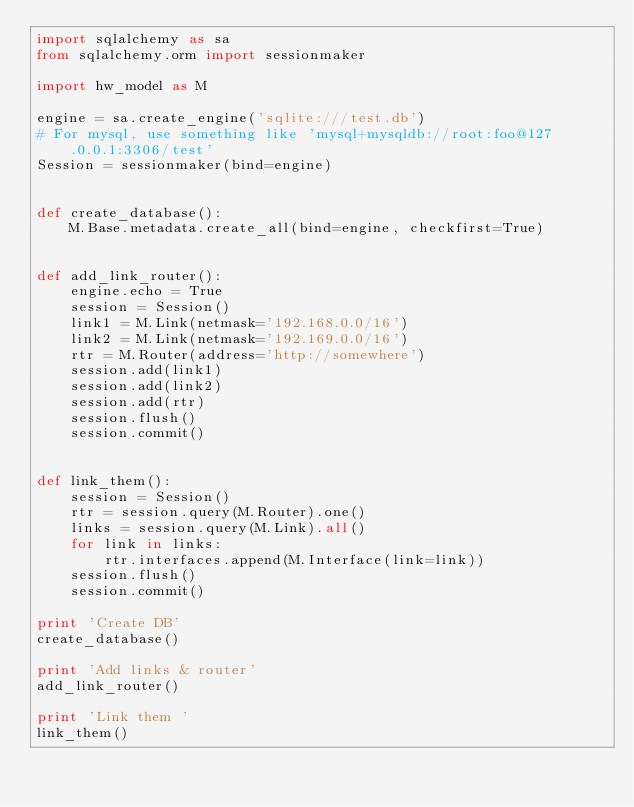<code> <loc_0><loc_0><loc_500><loc_500><_Python_>import sqlalchemy as sa
from sqlalchemy.orm import sessionmaker

import hw_model as M

engine = sa.create_engine('sqlite:///test.db')
# For mysql, use something like 'mysql+mysqldb://root:foo@127.0.0.1:3306/test'
Session = sessionmaker(bind=engine)


def create_database():
    M.Base.metadata.create_all(bind=engine, checkfirst=True)


def add_link_router():
    engine.echo = True
    session = Session()
    link1 = M.Link(netmask='192.168.0.0/16')
    link2 = M.Link(netmask='192.169.0.0/16')
    rtr = M.Router(address='http://somewhere')
    session.add(link1)
    session.add(link2)
    session.add(rtr)
    session.flush()
    session.commit()


def link_them():
    session = Session()
    rtr = session.query(M.Router).one()
    links = session.query(M.Link).all()
    for link in links:
        rtr.interfaces.append(M.Interface(link=link))
    session.flush()
    session.commit()

print 'Create DB'
create_database()

print 'Add links & router'
add_link_router()

print 'Link them '
link_them()
</code> 